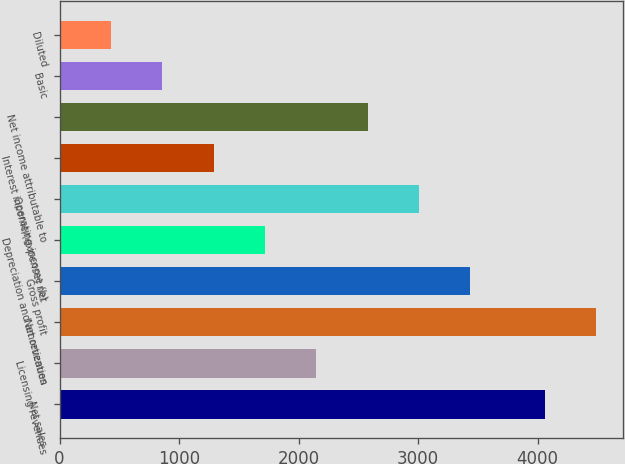Convert chart to OTSL. <chart><loc_0><loc_0><loc_500><loc_500><bar_chart><fcel>Net sales<fcel>Licensing revenues<fcel>Net revenues<fcel>Gross profit<fcel>Depreciation and amortization<fcel>Operating income (b)<fcel>Interest income/(expense) net<fcel>Net income attributable to<fcel>Basic<fcel>Diluted<nl><fcel>4059.1<fcel>2147.8<fcel>4488.62<fcel>3436.36<fcel>1718.28<fcel>3006.84<fcel>1288.76<fcel>2577.32<fcel>859.24<fcel>429.72<nl></chart> 